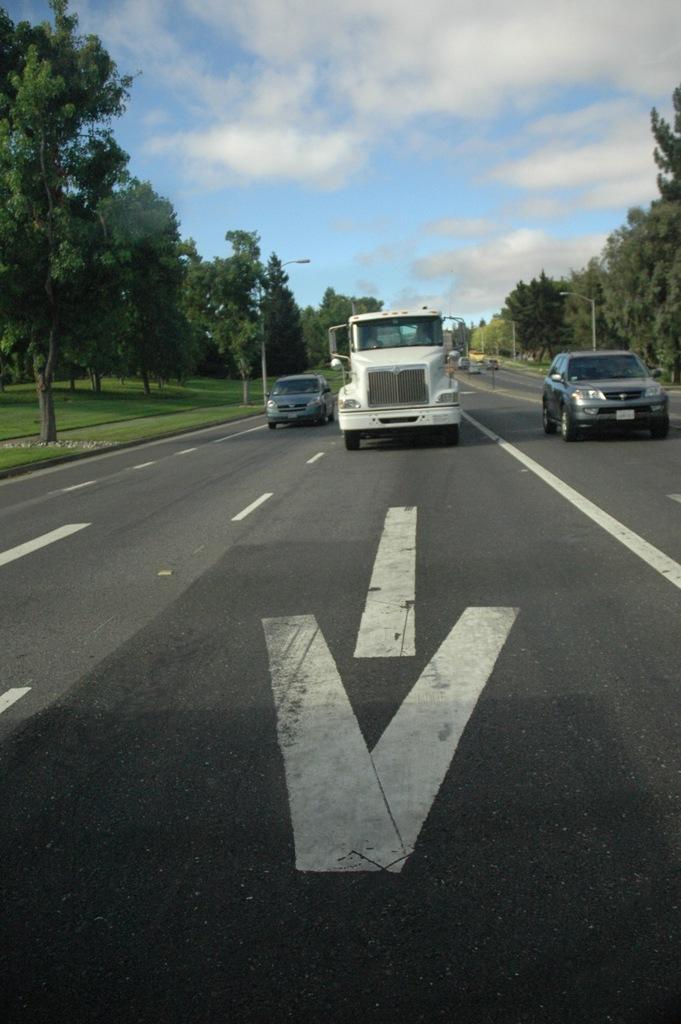In one or two sentences, can you explain what this image depicts? In the foreground of the picture it is road. In the center of the picture there are trees and vehicles moving on the road. At the top it is sky. 